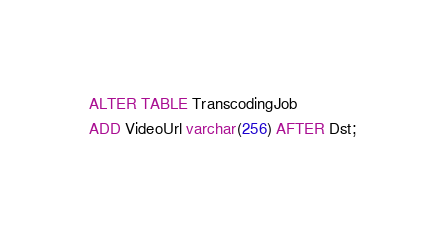<code> <loc_0><loc_0><loc_500><loc_500><_SQL_>ALTER TABLE TranscodingJob
ADD VideoUrl varchar(256) AFTER Dst;</code> 